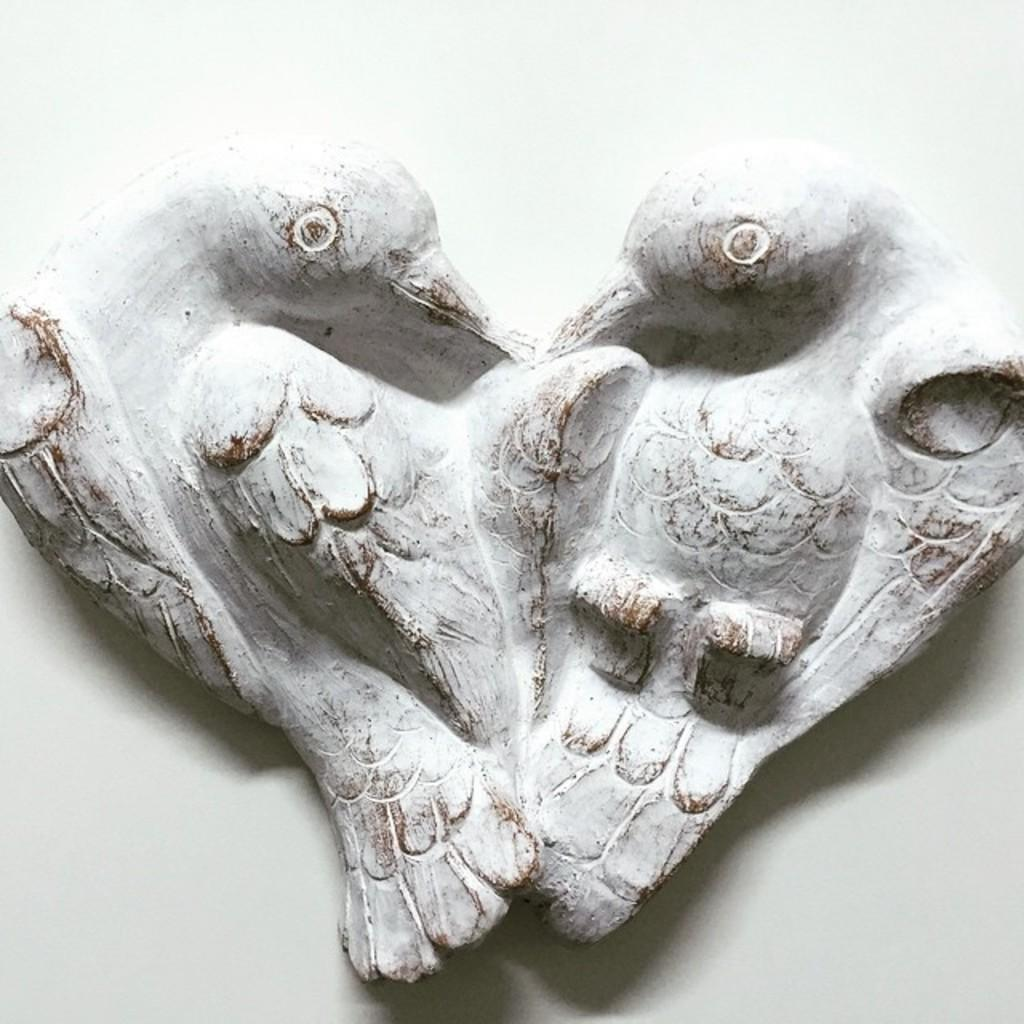What type of objects are depicted in the image? There are sculptures of two birds in the image. Where are the sculptures located? The sculptures are on a surface. What color is the background of the image? The background of the image is white in color. What type of receipt can be seen in the image? There is no receipt present in the image; it features sculptures of two birds on a surface with a white background. 